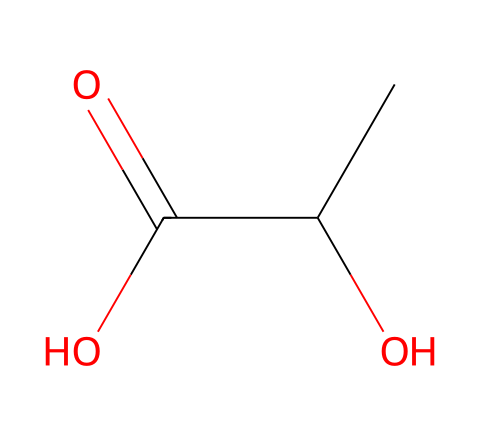What is the name of the chemical represented by the SMILES? The SMILES representation indicates a compound with a hydroxyl group (-OH) and carboxylic acid functional group (-COOH), which is characteristic of lactic acid.
Answer: lactic acid How many carbon atoms are in the chemical structure? By analyzing the SMILES, we see two carbon atoms in the backbone (CC) and one carbon in the carboxylic group (C(=O)), totaling three carbon atoms.
Answer: three What type of functional groups does this compound contain? The chemical has a hydroxyl group (-OH) and a carboxylic acid group (-COOH), which are both characteristic of acids.
Answer: hydroxyl and carboxylic acid What is the total number of hydrogen atoms in the chemical structure? The chemical structure has 6 hydrogen atoms: two from the carbon backbone and four from the functional groups (two from -OH and two from -COOH).
Answer: six Is this chemical a strong or weak acid? Lactic acid is classified as a weak acid due to its partial dissociation in water, which is indicated by the presence of the carboxylic acid moiety.
Answer: weak acid How does the presence of the hydroxyl group affect the chemical's properties? The hydroxyl group is hydrophilic and increases the solubility of lactic acid in water, influencing its behavior as an acid.
Answer: increases solubility What is the role of lactic acid in the human body during intense studying? Lactic acid is produced in the body as a result of anaerobic metabolism when energy demands exceed oxygen supply, such as during intense mental exertion, contributing to fatigue.
Answer: contributes to fatigue 